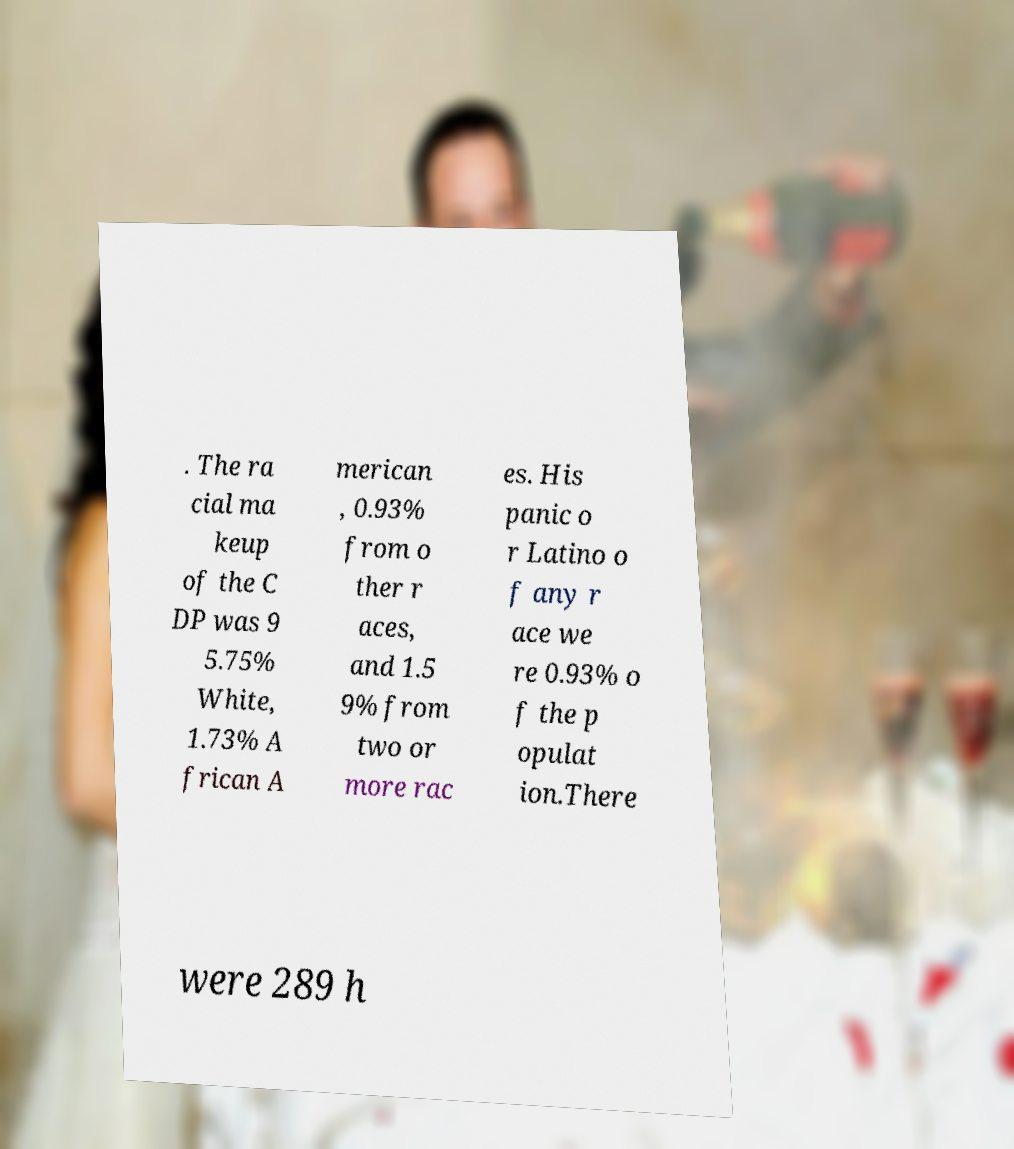Can you read and provide the text displayed in the image?This photo seems to have some interesting text. Can you extract and type it out for me? . The ra cial ma keup of the C DP was 9 5.75% White, 1.73% A frican A merican , 0.93% from o ther r aces, and 1.5 9% from two or more rac es. His panic o r Latino o f any r ace we re 0.93% o f the p opulat ion.There were 289 h 